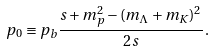Convert formula to latex. <formula><loc_0><loc_0><loc_500><loc_500>p _ { 0 } \equiv p _ { b } \frac { s + m _ { p } ^ { 2 } - ( m _ { \Lambda } + m _ { K } ) ^ { 2 } } { 2 s } \, .</formula> 